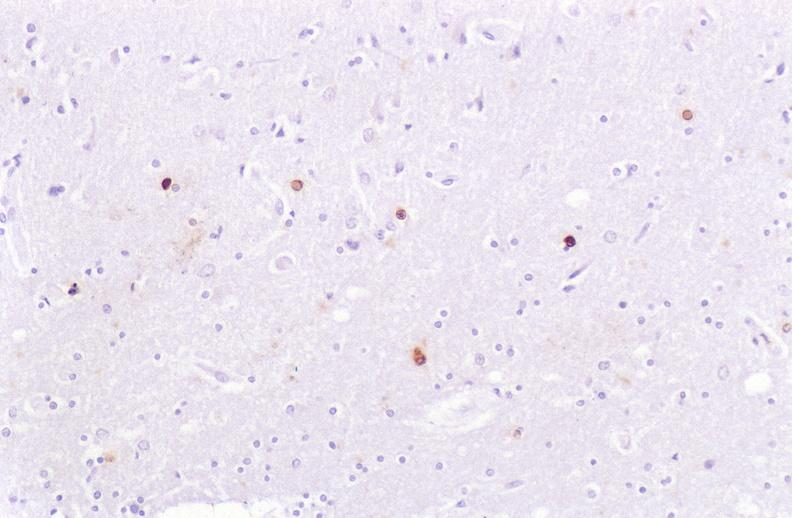does normal ovary show brain, herpes simplex virus immunohistochemistry?
Answer the question using a single word or phrase. No 